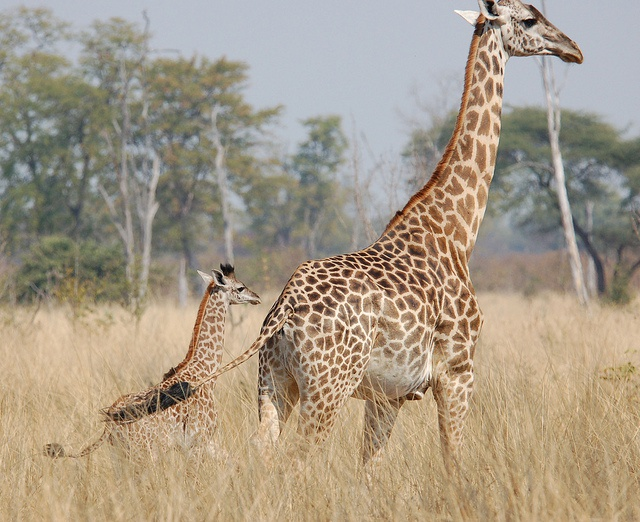Describe the objects in this image and their specific colors. I can see giraffe in darkgray, gray, and tan tones and giraffe in darkgray, tan, and gray tones in this image. 